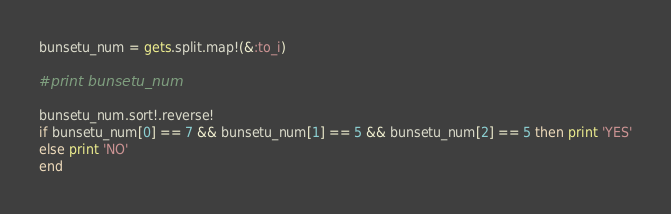Convert code to text. <code><loc_0><loc_0><loc_500><loc_500><_Ruby_>bunsetu_num = gets.split.map!(&:to_i)

#print bunsetu_num

bunsetu_num.sort!.reverse!
if bunsetu_num[0] == 7 && bunsetu_num[1] == 5 && bunsetu_num[2] == 5 then print 'YES'
else print 'NO'
end</code> 